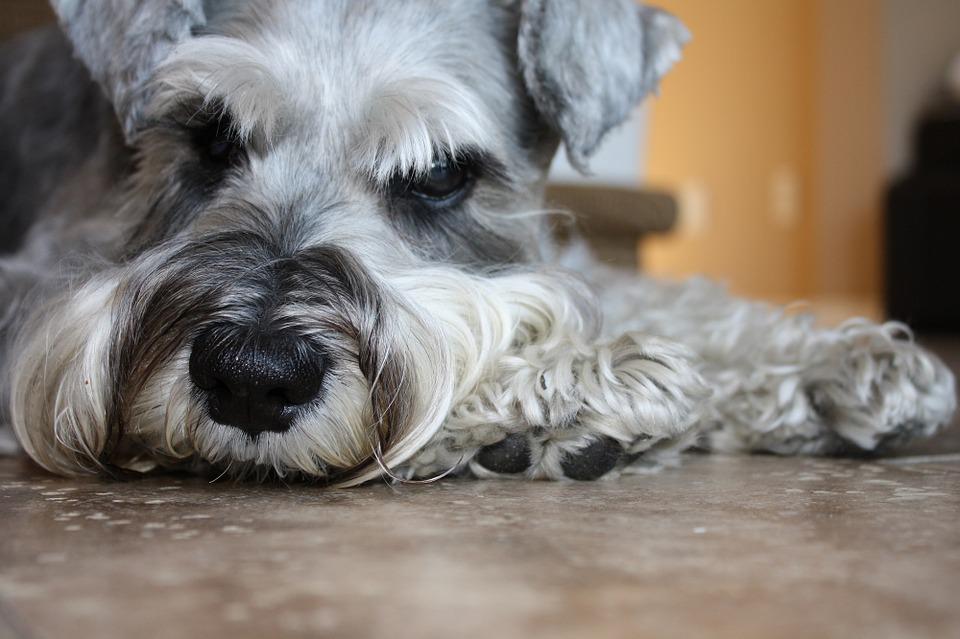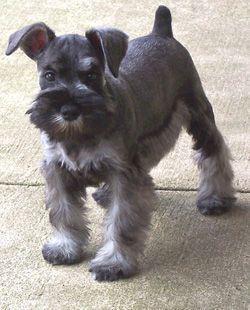The first image is the image on the left, the second image is the image on the right. Examine the images to the left and right. Is the description "A dog poses in one of the images, on a table, in front of a green wall." accurate? Answer yes or no. No. The first image is the image on the left, the second image is the image on the right. Analyze the images presented: Is the assertion "the right image has a dog on a gray floor mat and green walls" valid? Answer yes or no. No. 